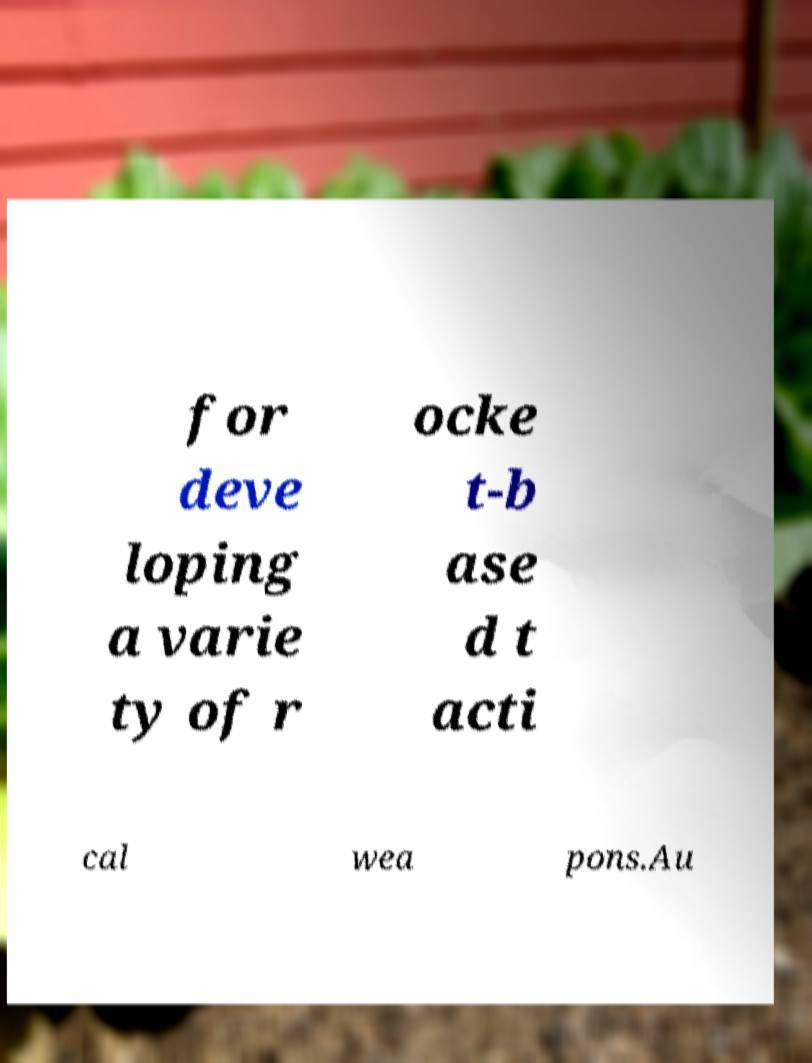Can you read and provide the text displayed in the image?This photo seems to have some interesting text. Can you extract and type it out for me? for deve loping a varie ty of r ocke t-b ase d t acti cal wea pons.Au 